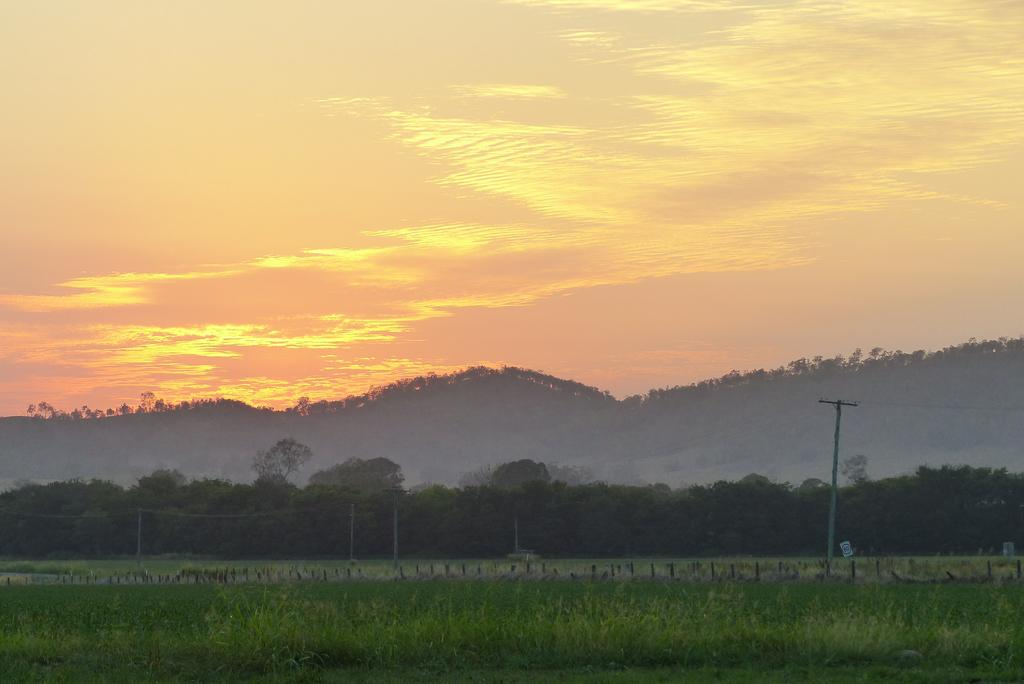What type of vegetation is present in the image? There is grass in the image. What structures can be seen in the image? There are poles in the image. What other natural elements are visible in the image? There are trees and mountains in the image. What part of the natural environment is visible in the image? The sky is visible in the image. What type of key is used to unlock the mountains in the image? There is no key present in the image, and the mountains are not locked. 